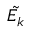Convert formula to latex. <formula><loc_0><loc_0><loc_500><loc_500>\tilde { E _ { k } }</formula> 